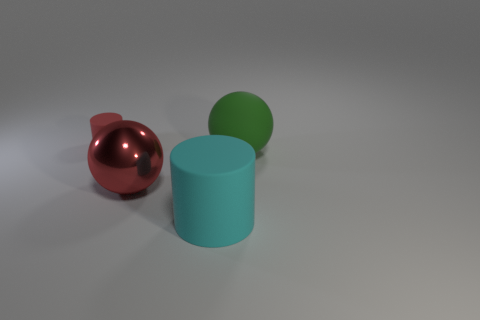Add 4 large purple things. How many objects exist? 8 Subtract 1 spheres. How many spheres are left? 1 Subtract all red balls. How many balls are left? 1 Add 2 big cylinders. How many big cylinders exist? 3 Subtract 0 brown cylinders. How many objects are left? 4 Subtract all purple balls. Subtract all yellow cylinders. How many balls are left? 2 Subtract all metallic balls. Subtract all cyan metal cubes. How many objects are left? 3 Add 4 small rubber cylinders. How many small rubber cylinders are left? 5 